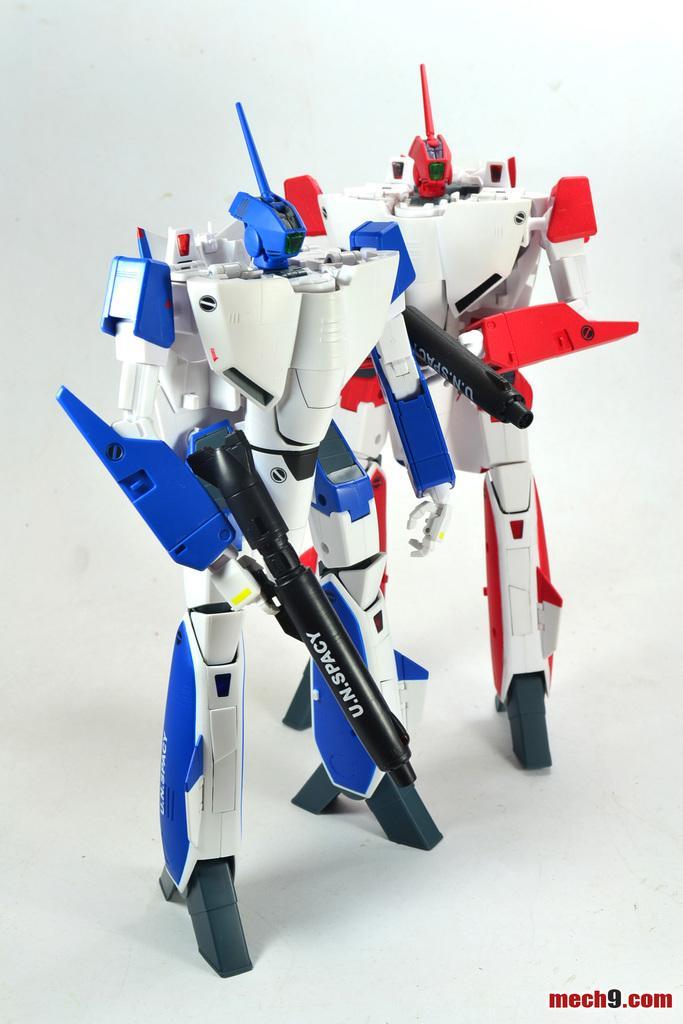Can you describe this image briefly? In this picture I can observe two toys on the white color surface. The toys are in white, blue and red colors. The background is in white color. 